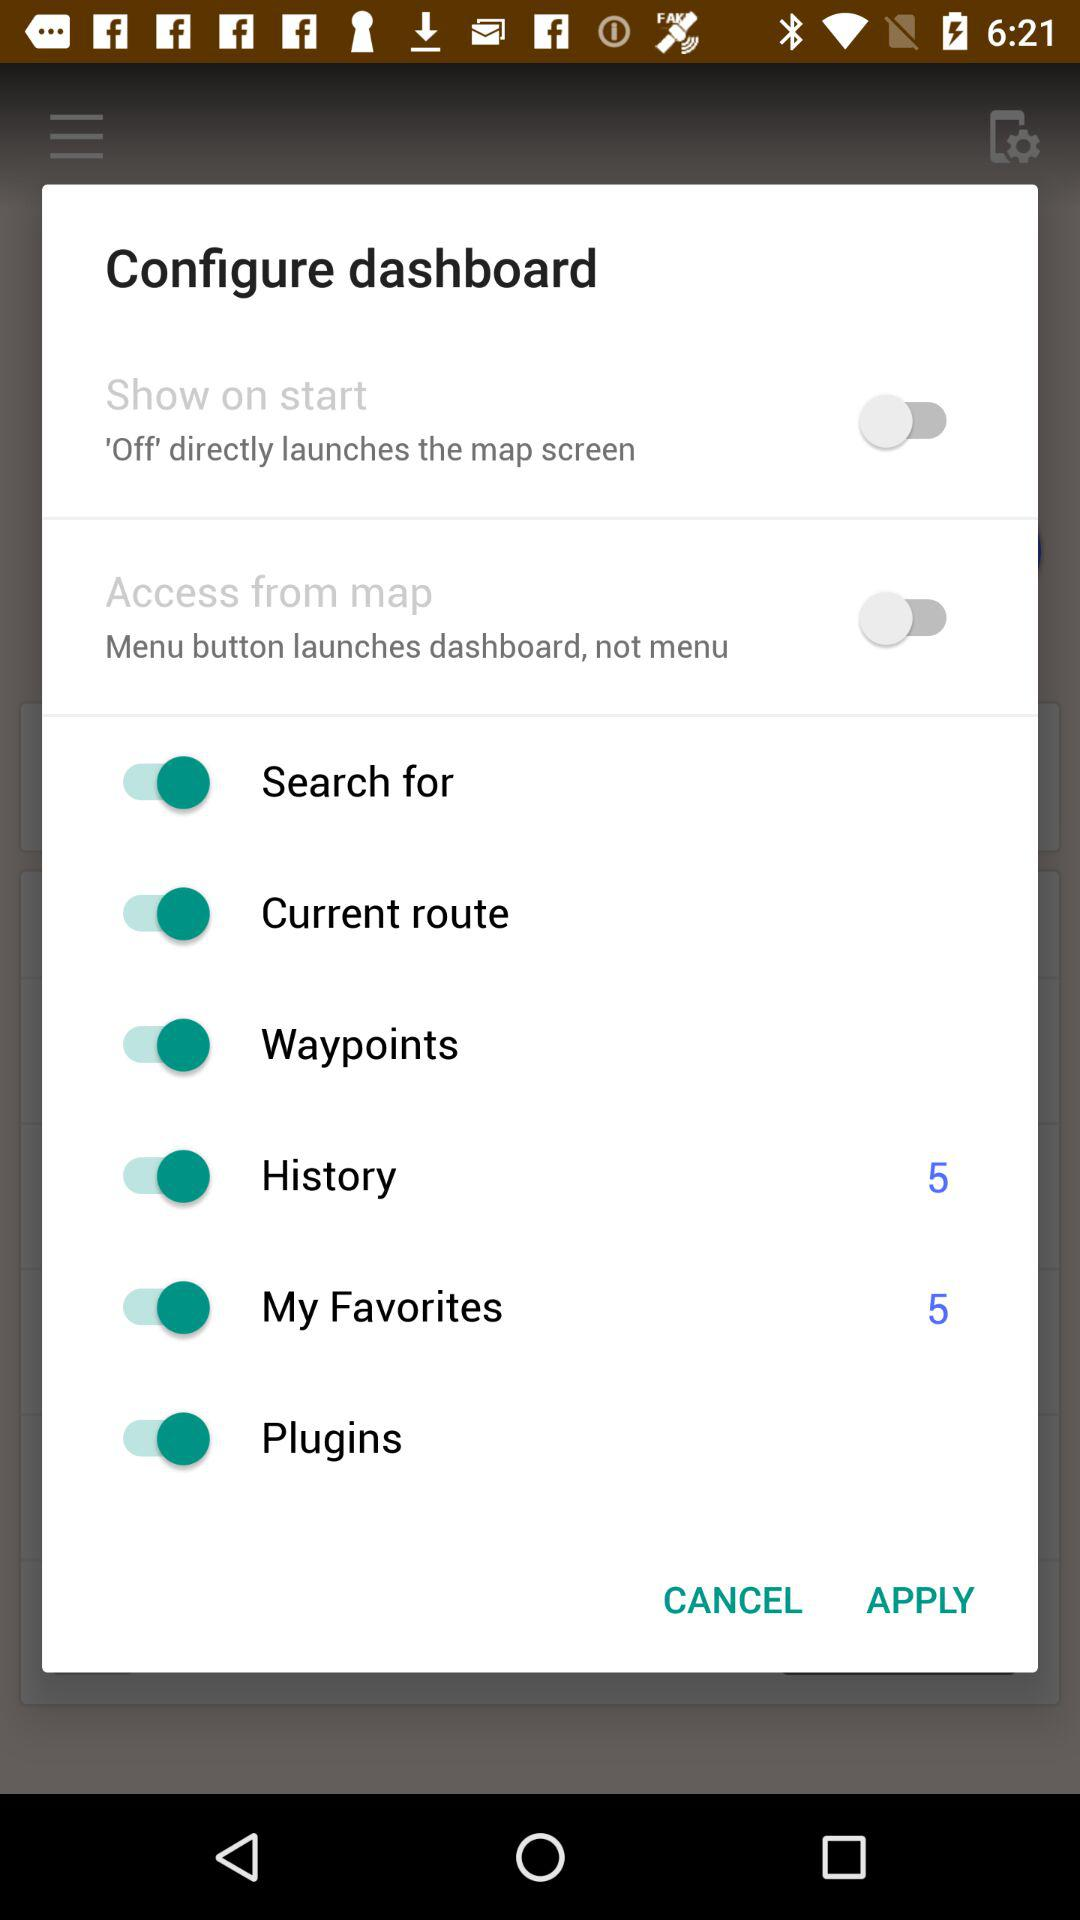What is the status of "History"? The status is "on". 